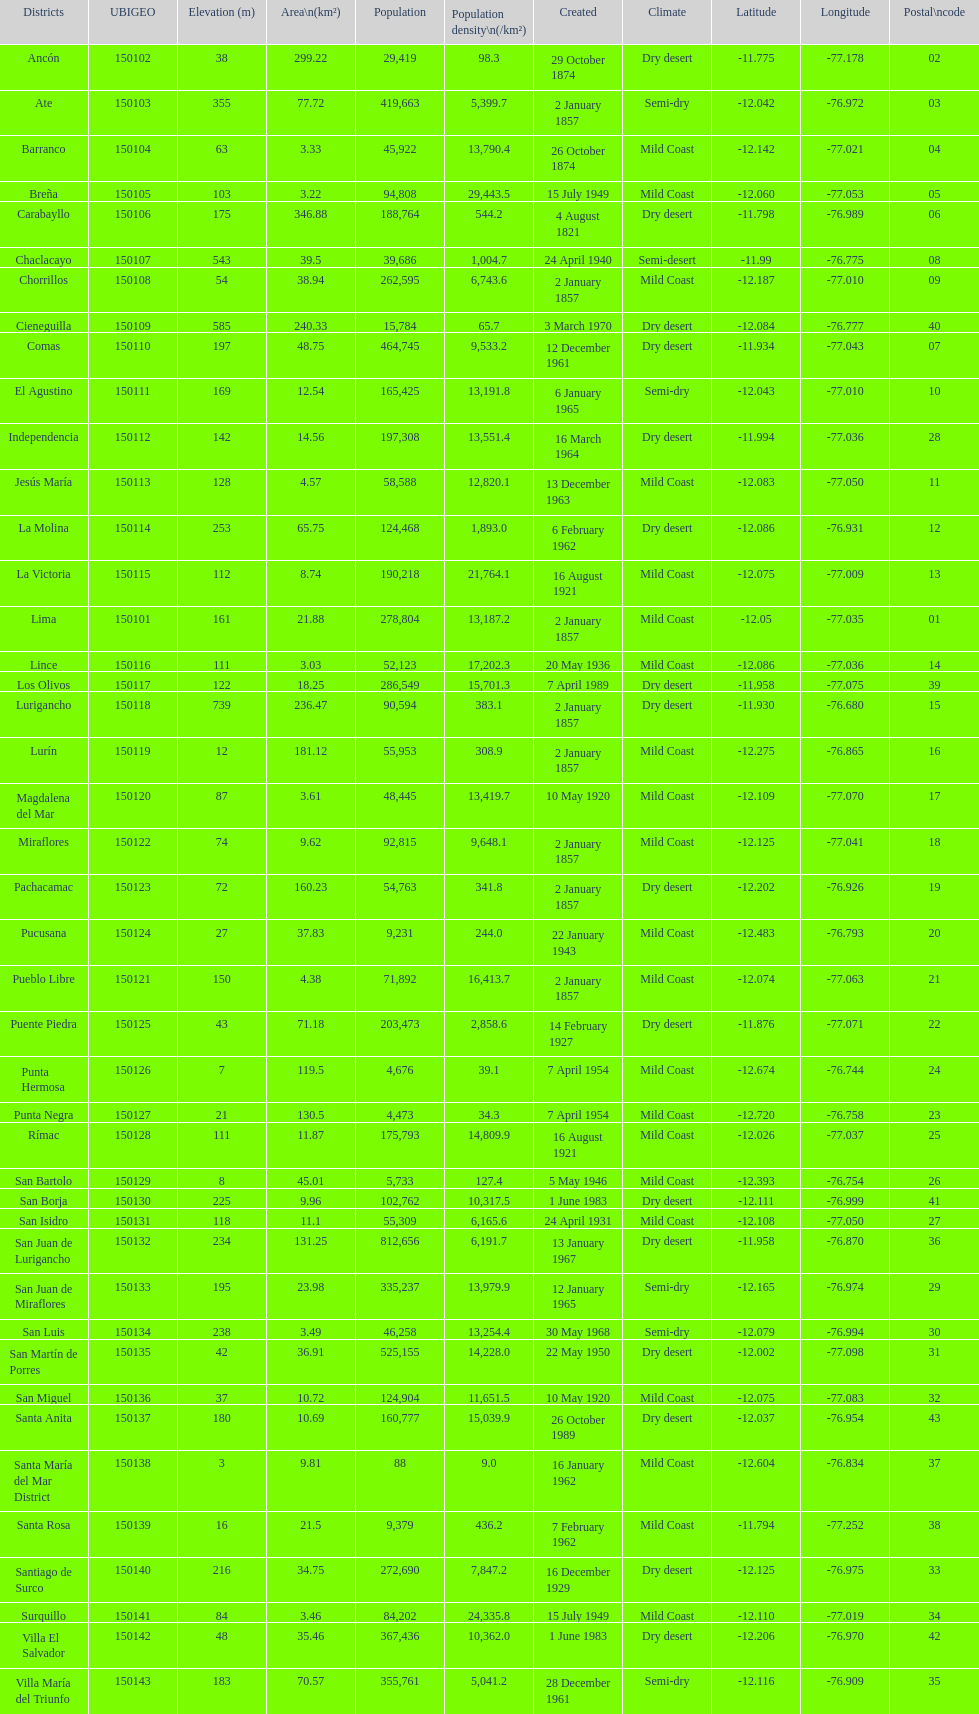What is the total number of districts of lima? 43. 